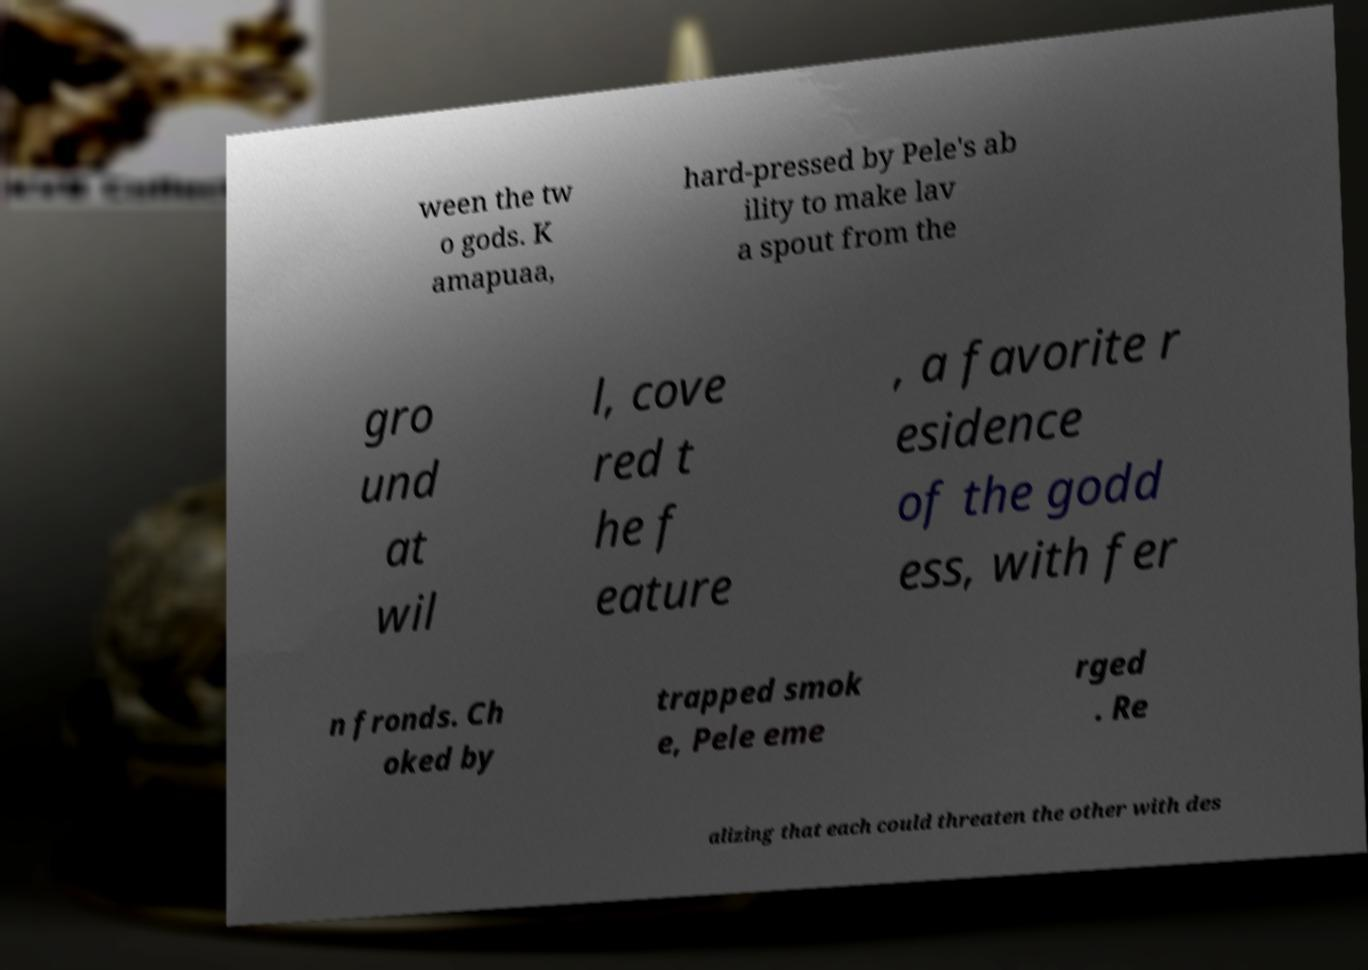Could you extract and type out the text from this image? ween the tw o gods. K amapuaa, hard-pressed by Pele's ab ility to make lav a spout from the gro und at wil l, cove red t he f eature , a favorite r esidence of the godd ess, with fer n fronds. Ch oked by trapped smok e, Pele eme rged . Re alizing that each could threaten the other with des 